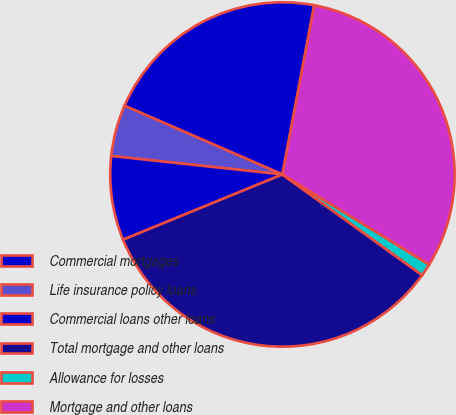Convert chart to OTSL. <chart><loc_0><loc_0><loc_500><loc_500><pie_chart><fcel>Commercial mortgages<fcel>Life insurance policy loans<fcel>Commercial loans other loans<fcel>Total mortgage and other loans<fcel>Allowance for losses<fcel>Mortgage and other loans<nl><fcel>21.42%<fcel>4.82%<fcel>7.9%<fcel>33.88%<fcel>1.17%<fcel>30.8%<nl></chart> 